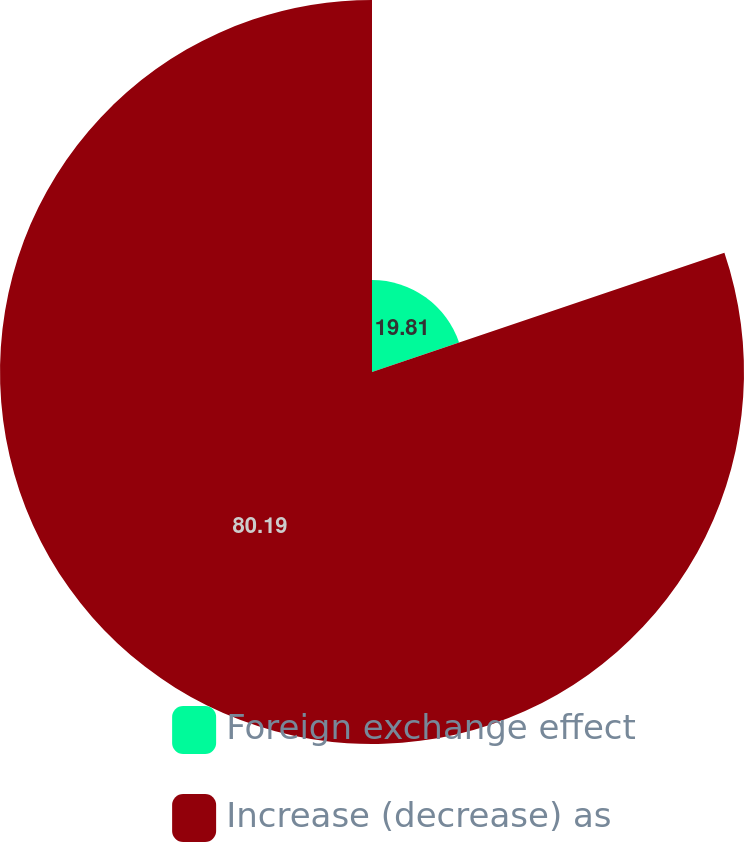<chart> <loc_0><loc_0><loc_500><loc_500><pie_chart><fcel>Foreign exchange effect<fcel>Increase (decrease) as<nl><fcel>19.81%<fcel>80.19%<nl></chart> 